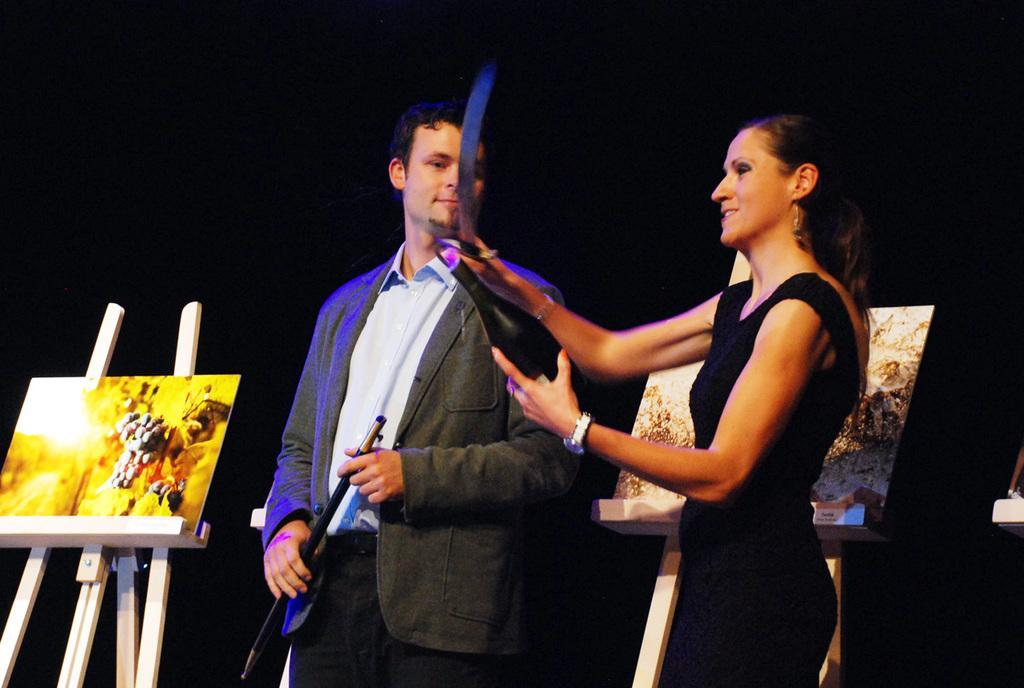Describe this image in one or two sentences. In this image we can see a woman wearing black dress is holding a bottle and a sword in her hands also we can see a man wearing a blazer and shirt is holding a stick. Here we can see two drawing boards with stands. The background of the image is dark. 